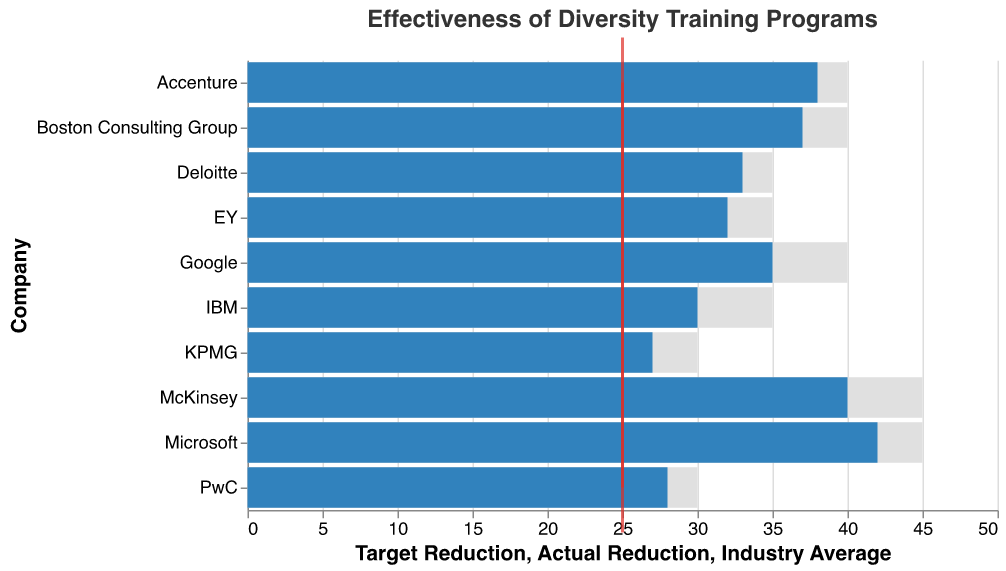What is the title of the chart? The title of the chart is written at the top in a larger font, indicating the overall subject of the visualization.
Answer: Effectiveness of Diversity Training Programs How many companies are shown in the chart? Count the number of different company names on the y-axis. There are ten rows, each representing a different company.
Answer: 10 Which company achieved the highest actual reduction in workplace discrimination incidents? Find the company with the longest blue bar, as this indicates the highest actual reduction. Microsoft has the longest blue bar.
Answer: Microsoft What is the target reduction for Google? Look at the gray bar for Google and find the endpoint value, which represents the target reduction.
Answer: 40 Did any company meet or exceed their target reduction? Compare the lengths of blue bars (actual reductions) with gray bars (target reductions) for each company. No company's blue bar reaches or exceeds the endpoint of their gray bar.
Answer: No What is the average actual reduction in discrimination incidents for all companies? Sum the actual reductions and then divide by the number of companies: (35 + 42+ 30 + 38 + 33 + 28 + 32 + 27 + 40 + 37) / 10.
Answer: 34.2 How does Accenture's actual reduction compare to the industry average? Compare Accenture's actual reduction (length of blue bar) to the industry average tick mark (red line) and note the difference. Accenture's actual reduction (38) is higher than the industry average (25).
Answer: Higher Which companies have an actual reduction within 5 points of their target reduction? Compare the actual reduction and target reduction values for each company. Find those where the difference is 5 or less: Google (5), IBM (5), Deloitte (2), PwC (2), EY (3), KPMG (3), and Boston Consulting Group (3).
Answer: Google, IBM, Deloitte, PwC, EY, KPMG, Boston Consulting Group Which company has the smallest difference between its actual reduction and the industry average? Calculate the difference between the actual reduction and industry average for each company, and find the smallest value: KPMG (27 - 25 = 2).
Answer: KPMG What is the median target reduction among all companies? List the target reduction values, sort them, and find the median: [30, 30, 35, 35, 35, 35, 40, 40, 40, 45, 45]. The median is the middle value.
Answer: 35 